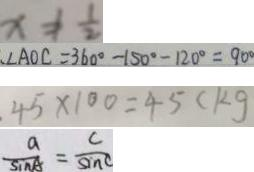<formula> <loc_0><loc_0><loc_500><loc_500>x \neq \frac { 1 } { 2 } 
 . \angle A O C = 3 6 0 ^ { \circ } - 1 5 0 ^ { \circ } - 1 2 0 ^ { \circ } = 9 0 ^ { \circ } 
 . 4 5 \times 1 0 0 = 4 5 ( k g 
 \frac { a } { \sin A } = \frac { c } { \sin C }</formula> 